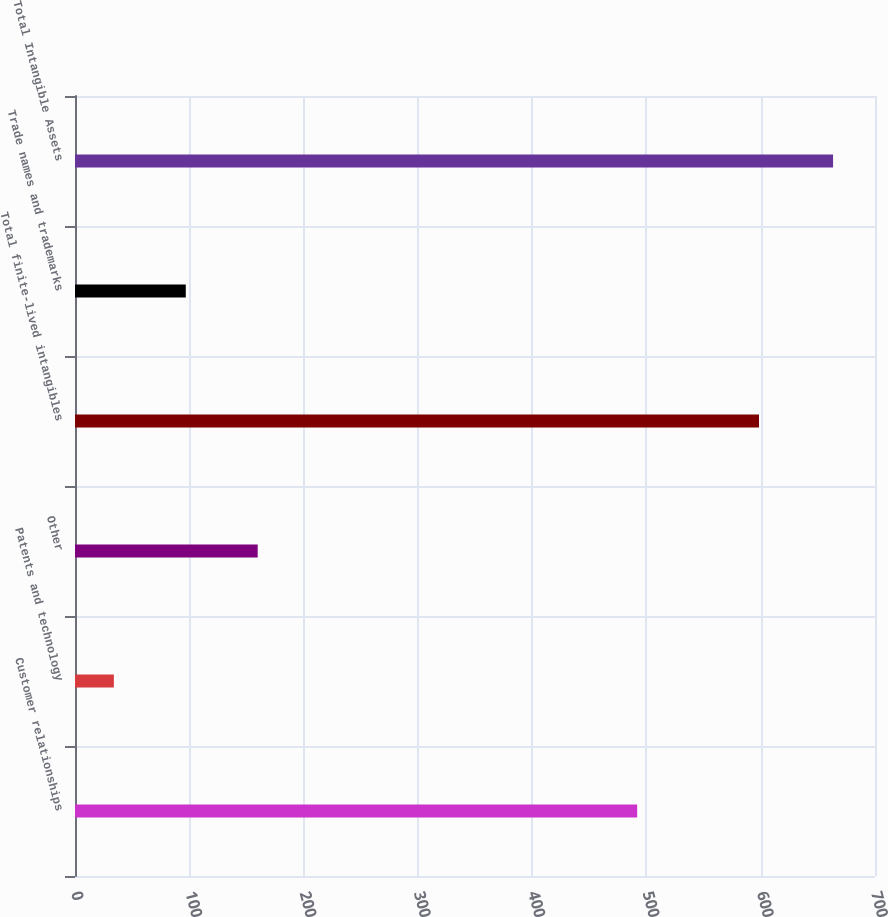<chart> <loc_0><loc_0><loc_500><loc_500><bar_chart><fcel>Customer relationships<fcel>Patents and technology<fcel>Other<fcel>Total finite-lived intangibles<fcel>Trade names and trademarks<fcel>Total Intangible Assets<nl><fcel>491.9<fcel>34<fcel>159.86<fcel>598.5<fcel>96.93<fcel>663.3<nl></chart> 